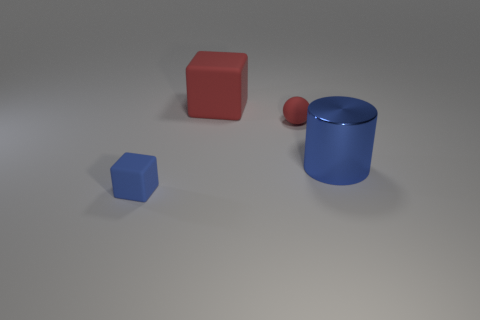There is a rubber thing in front of the big shiny cylinder; is it the same shape as the big object behind the red rubber ball?
Your answer should be very brief. Yes. What is the shape of the red matte object that is the same size as the blue shiny object?
Make the answer very short. Cube. Is the number of large objects that are in front of the large blue metallic cylinder the same as the number of red things behind the tiny blue matte block?
Make the answer very short. No. Are there any other things that are the same shape as the blue shiny object?
Your response must be concise. No. Is the material of the red object that is in front of the big block the same as the large red thing?
Offer a very short reply. Yes. What material is the blue cylinder that is the same size as the red cube?
Your answer should be very brief. Metal. What number of other objects are the same material as the big blue thing?
Your answer should be very brief. 0. There is a blue metallic thing; does it have the same size as the matte thing that is in front of the small red ball?
Your answer should be compact. No. Are there fewer red rubber cubes to the left of the metallic thing than matte things that are to the left of the small rubber sphere?
Offer a terse response. Yes. What is the size of the cube that is in front of the ball?
Your answer should be compact. Small. 